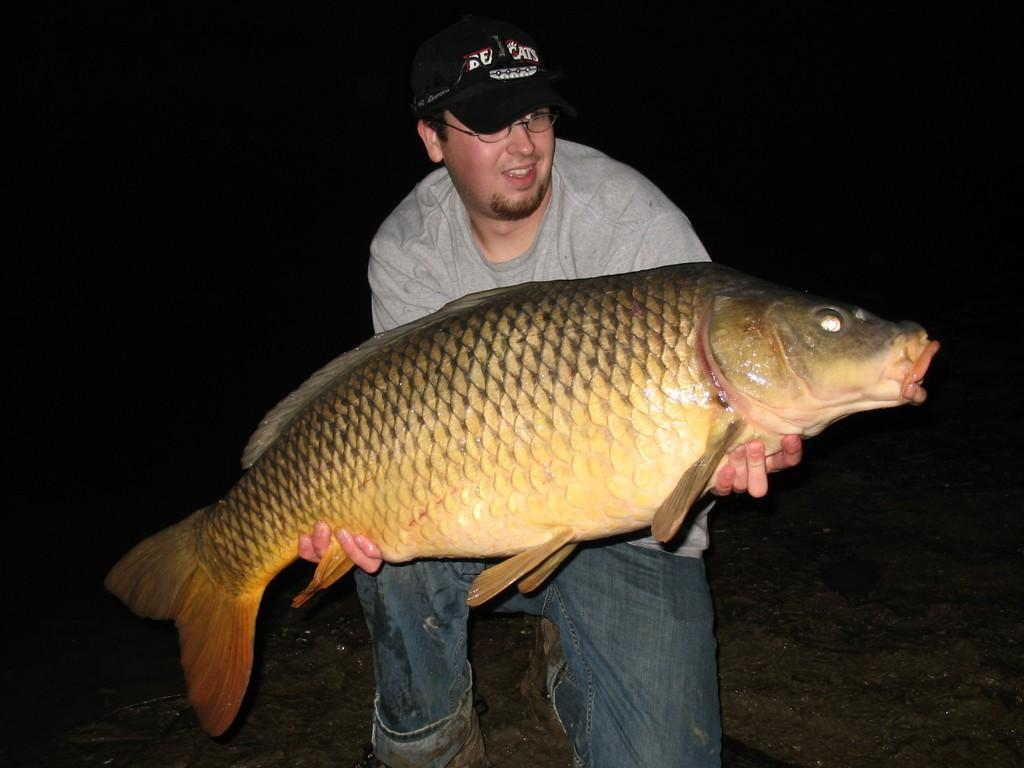What is the main subject of the picture? The main subject of the picture is a man. Can you describe the man's attire in the image? The man is wearing a cap, spectacles, a t-shirt, jeans, and shoes. What is the man holding in the image? The man is holding a big fish. What is the condition of the background in the image? The background of the image appears to be dark. What is the price of the ring on the man's finger in the image? There is no ring visible on the man's finger in the image. How many cracks can be seen on the man's shoes in the image? There are no cracks visible on the man's shoes in the image. 